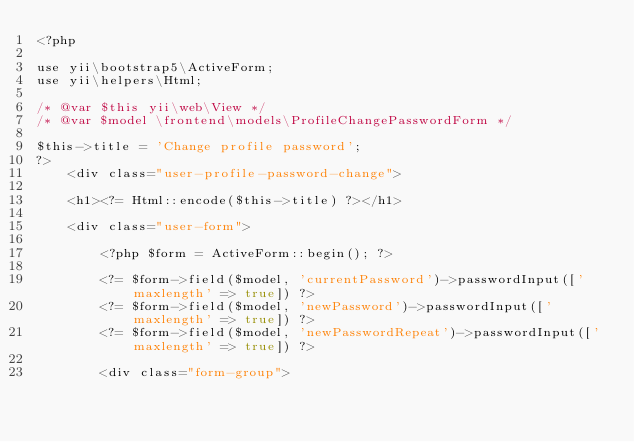Convert code to text. <code><loc_0><loc_0><loc_500><loc_500><_PHP_><?php

use yii\bootstrap5\ActiveForm;
use yii\helpers\Html;

/* @var $this yii\web\View */
/* @var $model \frontend\models\ProfileChangePasswordForm */

$this->title = 'Change profile password';
?>
    <div class="user-profile-password-change">

    <h1><?= Html::encode($this->title) ?></h1>

    <div class="user-form">

        <?php $form = ActiveForm::begin(); ?>

        <?= $form->field($model, 'currentPassword')->passwordInput(['maxlength' => true]) ?>
        <?= $form->field($model, 'newPassword')->passwordInput(['maxlength' => true]) ?>
        <?= $form->field($model, 'newPasswordRepeat')->passwordInput(['maxlength' => true]) ?>

        <div class="form-group"></code> 